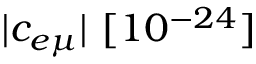<formula> <loc_0><loc_0><loc_500><loc_500>| c _ { e \mu } | [ 1 0 ^ { - 2 4 } ]</formula> 